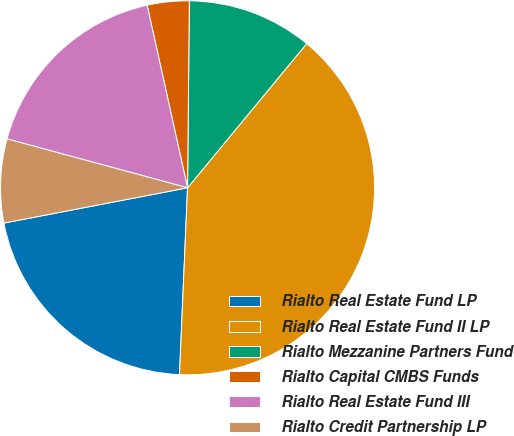<chart> <loc_0><loc_0><loc_500><loc_500><pie_chart><fcel>Rialto Real Estate Fund LP<fcel>Rialto Real Estate Fund II LP<fcel>Rialto Mezzanine Partners Fund<fcel>Rialto Capital CMBS Funds<fcel>Rialto Real Estate Fund III<fcel>Rialto Credit Partnership LP<nl><fcel>21.29%<fcel>39.69%<fcel>10.84%<fcel>3.62%<fcel>17.32%<fcel>7.23%<nl></chart> 